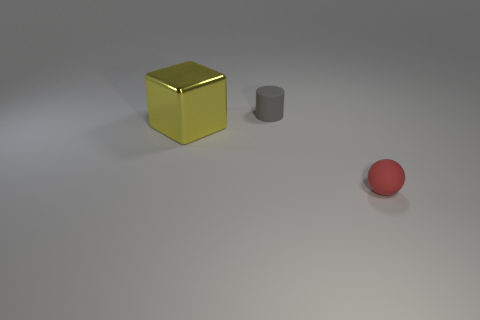Is there any other thing that has the same size as the yellow metal block?
Keep it short and to the point. No. Are there any other things that have the same material as the red sphere?
Keep it short and to the point. Yes. What is the size of the rubber object to the right of the tiny matte object left of the tiny red matte thing?
Provide a short and direct response. Small. There is a rubber object that is to the left of the small rubber thing that is right of the gray cylinder on the left side of the small red object; what is its size?
Keep it short and to the point. Small. Does the small object behind the tiny red matte object have the same shape as the tiny object that is right of the matte cylinder?
Ensure brevity in your answer.  No. Does the matte thing in front of the cube have the same size as the cylinder?
Provide a succinct answer. Yes. Is the object that is on the left side of the tiny gray object made of the same material as the tiny object that is on the left side of the red matte ball?
Provide a short and direct response. No. Are there any other rubber spheres that have the same size as the red sphere?
Provide a succinct answer. No. There is a rubber object right of the tiny matte thing that is behind the rubber object that is to the right of the small gray cylinder; what shape is it?
Give a very brief answer. Sphere. Are there more rubber things to the right of the tiny sphere than tiny yellow metal cubes?
Ensure brevity in your answer.  No. 